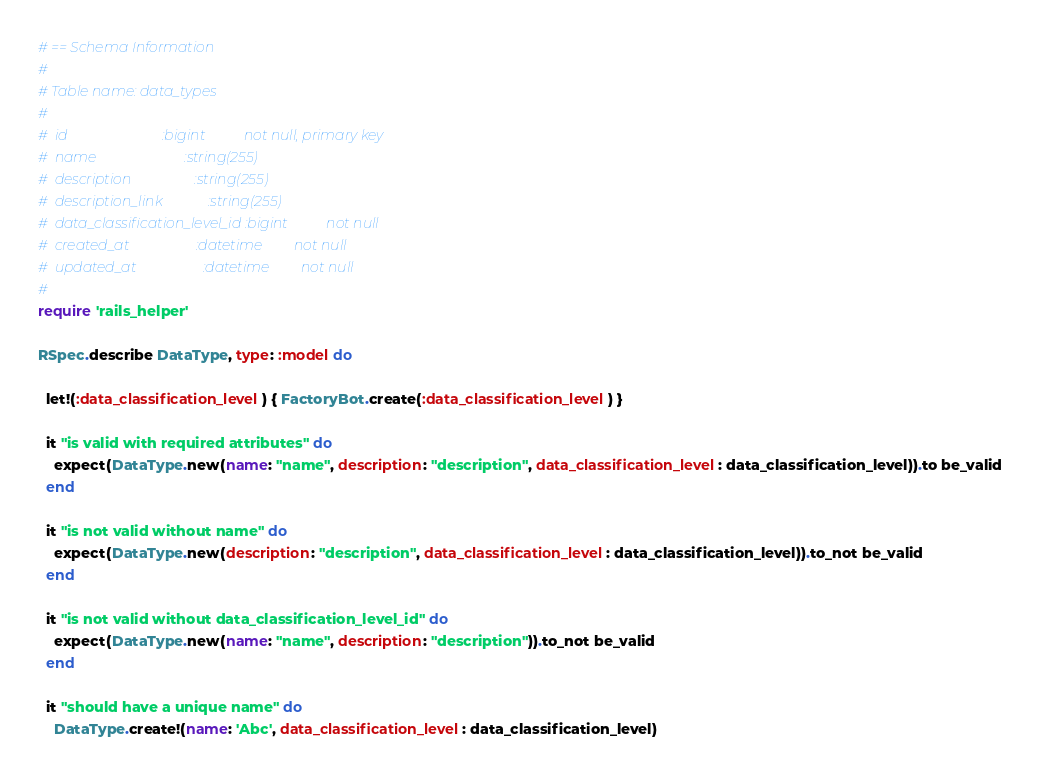Convert code to text. <code><loc_0><loc_0><loc_500><loc_500><_Ruby_># == Schema Information
#
# Table name: data_types
#
#  id                           :bigint           not null, primary key
#  name                         :string(255)
#  description                  :string(255)
#  description_link             :string(255)
#  data_classification_level_id :bigint           not null
#  created_at                   :datetime         not null
#  updated_at                   :datetime         not null
#
require 'rails_helper'

RSpec.describe DataType, type: :model do

  let!(:data_classification_level) { FactoryBot.create(:data_classification_level) }

  it "is valid with required attributes" do
    expect(DataType.new(name: "name", description: "description", data_classification_level: data_classification_level)).to be_valid
  end

  it "is not valid without name" do
    expect(DataType.new(description: "description", data_classification_level: data_classification_level)).to_not be_valid
  end

  it "is not valid without data_classification_level_id" do
    expect(DataType.new(name: "name", description: "description")).to_not be_valid
  end

  it "should have a unique name" do
    DataType.create!(name: 'Abc', data_classification_level: data_classification_level)</code> 